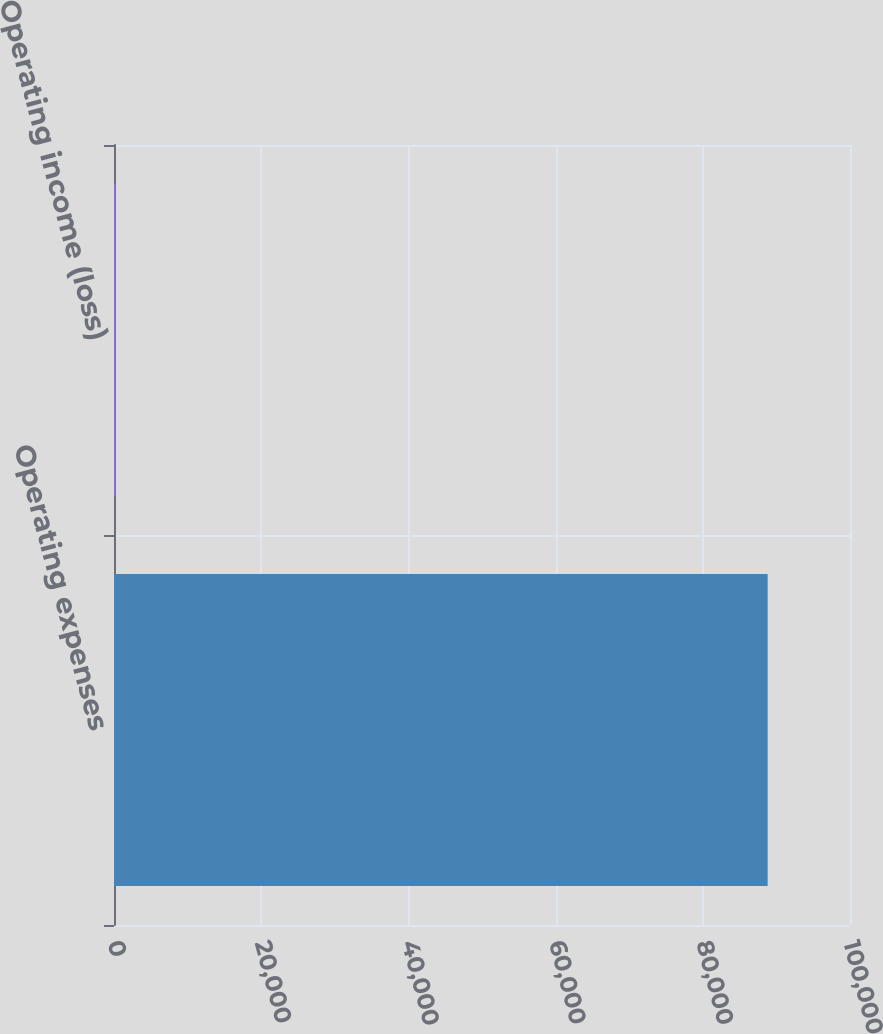<chart> <loc_0><loc_0><loc_500><loc_500><bar_chart><fcel>Operating expenses<fcel>Operating income (loss)<nl><fcel>88810<fcel>178<nl></chart> 